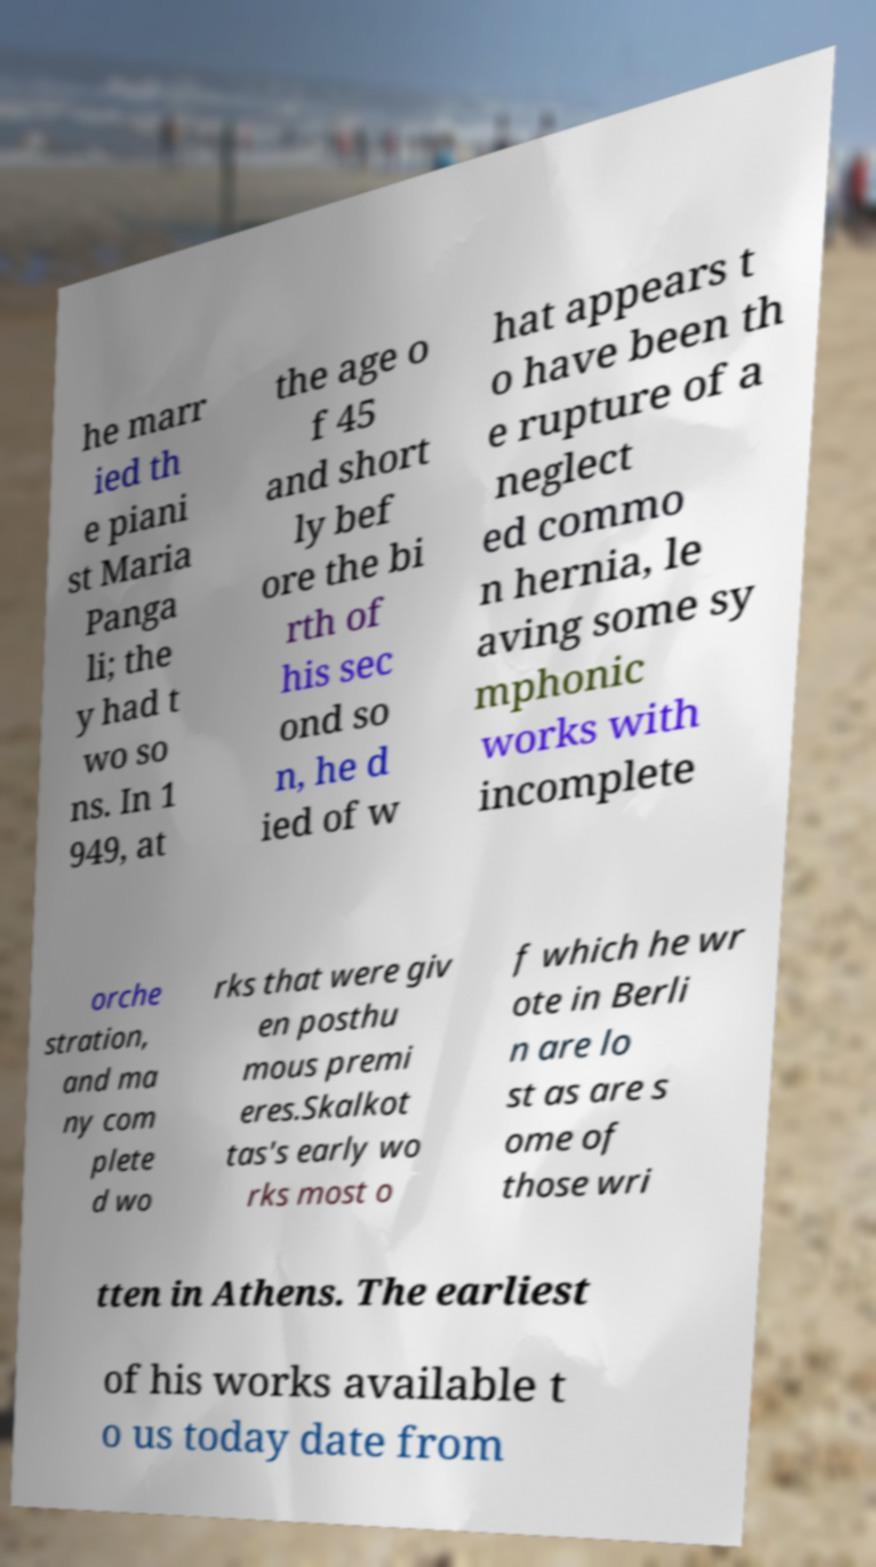Can you read and provide the text displayed in the image?This photo seems to have some interesting text. Can you extract and type it out for me? he marr ied th e piani st Maria Panga li; the y had t wo so ns. In 1 949, at the age o f 45 and short ly bef ore the bi rth of his sec ond so n, he d ied of w hat appears t o have been th e rupture of a neglect ed commo n hernia, le aving some sy mphonic works with incomplete orche stration, and ma ny com plete d wo rks that were giv en posthu mous premi eres.Skalkot tas's early wo rks most o f which he wr ote in Berli n are lo st as are s ome of those wri tten in Athens. The earliest of his works available t o us today date from 